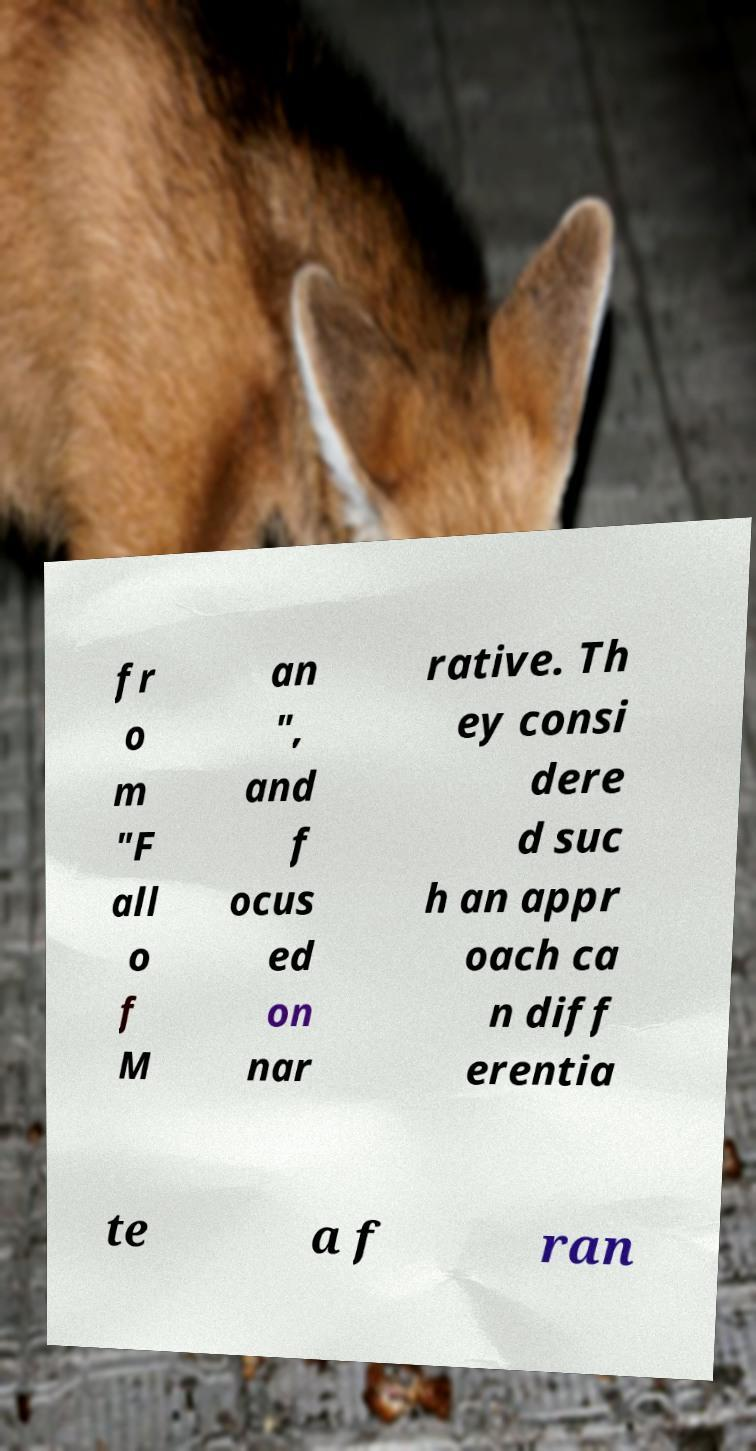Please identify and transcribe the text found in this image. fr o m "F all o f M an ", and f ocus ed on nar rative. Th ey consi dere d suc h an appr oach ca n diff erentia te a f ran 